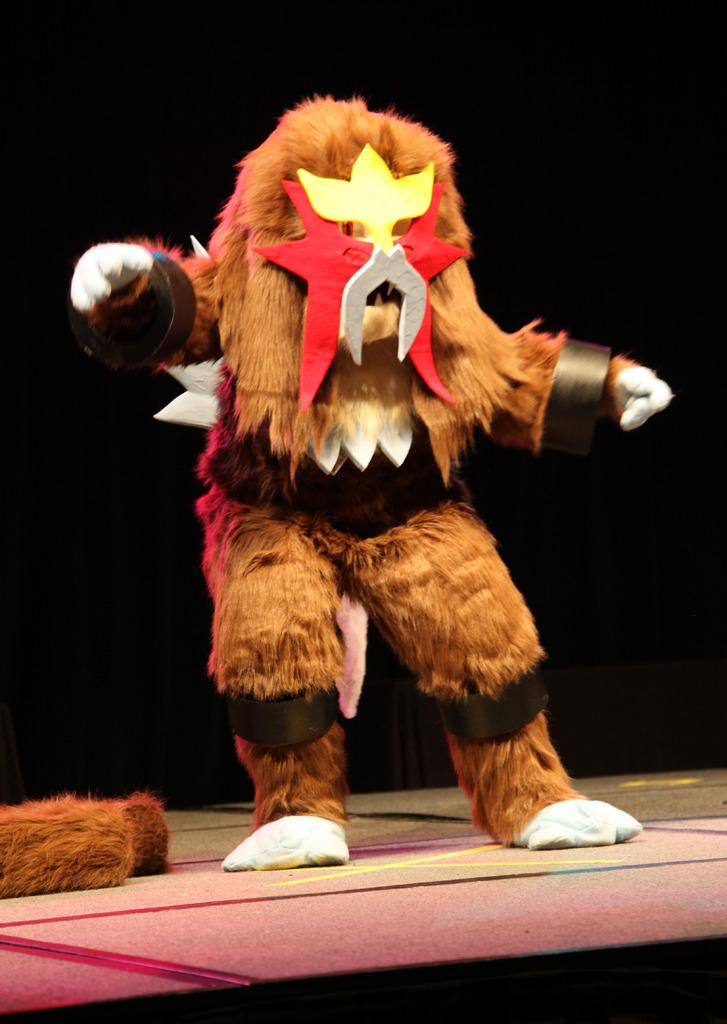What is the main subject of the image? There is a person in the image. What is the person wearing in the image? The person is wearing a costume in the image. Can you describe the background of the image? The background of the image is dark. How many rabbits can be seen sleeping in the image? There are no rabbits or sleeping figures present in the image. 